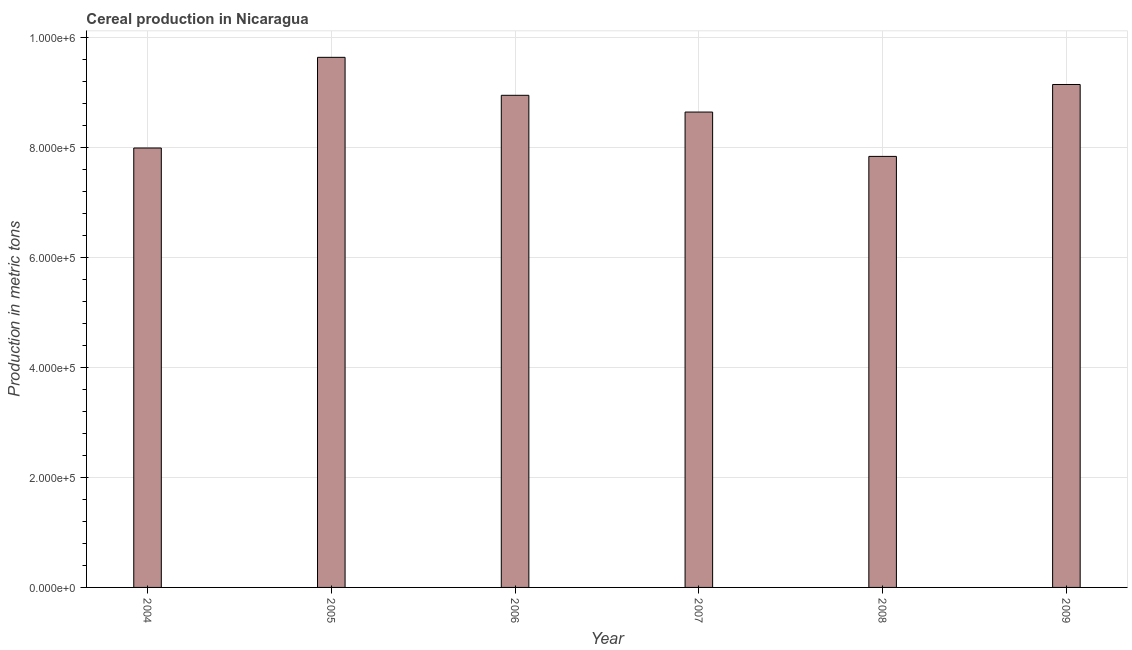Does the graph contain any zero values?
Your response must be concise. No. What is the title of the graph?
Give a very brief answer. Cereal production in Nicaragua. What is the label or title of the Y-axis?
Provide a succinct answer. Production in metric tons. What is the cereal production in 2006?
Provide a short and direct response. 8.95e+05. Across all years, what is the maximum cereal production?
Provide a short and direct response. 9.64e+05. Across all years, what is the minimum cereal production?
Provide a short and direct response. 7.84e+05. In which year was the cereal production maximum?
Give a very brief answer. 2005. What is the sum of the cereal production?
Provide a short and direct response. 5.22e+06. What is the difference between the cereal production in 2005 and 2006?
Provide a short and direct response. 6.90e+04. What is the average cereal production per year?
Give a very brief answer. 8.70e+05. What is the median cereal production?
Keep it short and to the point. 8.79e+05. Do a majority of the years between 2007 and 2005 (inclusive) have cereal production greater than 440000 metric tons?
Offer a very short reply. Yes. What is the ratio of the cereal production in 2007 to that in 2009?
Offer a very short reply. 0.94. What is the difference between the highest and the second highest cereal production?
Offer a terse response. 4.94e+04. Is the sum of the cereal production in 2006 and 2008 greater than the maximum cereal production across all years?
Provide a short and direct response. Yes. What is the difference between the highest and the lowest cereal production?
Your response must be concise. 1.80e+05. In how many years, is the cereal production greater than the average cereal production taken over all years?
Offer a very short reply. 3. How many bars are there?
Make the answer very short. 6. Are all the bars in the graph horizontal?
Provide a succinct answer. No. How many years are there in the graph?
Make the answer very short. 6. What is the Production in metric tons of 2004?
Your response must be concise. 7.99e+05. What is the Production in metric tons in 2005?
Your answer should be compact. 9.64e+05. What is the Production in metric tons in 2006?
Ensure brevity in your answer.  8.95e+05. What is the Production in metric tons of 2007?
Offer a very short reply. 8.64e+05. What is the Production in metric tons in 2008?
Your answer should be compact. 7.84e+05. What is the Production in metric tons of 2009?
Provide a succinct answer. 9.14e+05. What is the difference between the Production in metric tons in 2004 and 2005?
Offer a very short reply. -1.65e+05. What is the difference between the Production in metric tons in 2004 and 2006?
Give a very brief answer. -9.58e+04. What is the difference between the Production in metric tons in 2004 and 2007?
Ensure brevity in your answer.  -6.53e+04. What is the difference between the Production in metric tons in 2004 and 2008?
Give a very brief answer. 1.53e+04. What is the difference between the Production in metric tons in 2004 and 2009?
Give a very brief answer. -1.15e+05. What is the difference between the Production in metric tons in 2005 and 2006?
Your answer should be very brief. 6.90e+04. What is the difference between the Production in metric tons in 2005 and 2007?
Offer a very short reply. 9.95e+04. What is the difference between the Production in metric tons in 2005 and 2008?
Your answer should be very brief. 1.80e+05. What is the difference between the Production in metric tons in 2005 and 2009?
Offer a very short reply. 4.94e+04. What is the difference between the Production in metric tons in 2006 and 2007?
Provide a succinct answer. 3.04e+04. What is the difference between the Production in metric tons in 2006 and 2008?
Give a very brief answer. 1.11e+05. What is the difference between the Production in metric tons in 2006 and 2009?
Make the answer very short. -1.97e+04. What is the difference between the Production in metric tons in 2007 and 2008?
Provide a succinct answer. 8.06e+04. What is the difference between the Production in metric tons in 2007 and 2009?
Provide a short and direct response. -5.01e+04. What is the difference between the Production in metric tons in 2008 and 2009?
Provide a succinct answer. -1.31e+05. What is the ratio of the Production in metric tons in 2004 to that in 2005?
Provide a succinct answer. 0.83. What is the ratio of the Production in metric tons in 2004 to that in 2006?
Your response must be concise. 0.89. What is the ratio of the Production in metric tons in 2004 to that in 2007?
Give a very brief answer. 0.92. What is the ratio of the Production in metric tons in 2004 to that in 2008?
Provide a succinct answer. 1.02. What is the ratio of the Production in metric tons in 2004 to that in 2009?
Give a very brief answer. 0.87. What is the ratio of the Production in metric tons in 2005 to that in 2006?
Keep it short and to the point. 1.08. What is the ratio of the Production in metric tons in 2005 to that in 2007?
Your answer should be compact. 1.11. What is the ratio of the Production in metric tons in 2005 to that in 2008?
Offer a terse response. 1.23. What is the ratio of the Production in metric tons in 2005 to that in 2009?
Make the answer very short. 1.05. What is the ratio of the Production in metric tons in 2006 to that in 2007?
Ensure brevity in your answer.  1.03. What is the ratio of the Production in metric tons in 2006 to that in 2008?
Offer a very short reply. 1.14. What is the ratio of the Production in metric tons in 2007 to that in 2008?
Your answer should be very brief. 1.1. What is the ratio of the Production in metric tons in 2007 to that in 2009?
Offer a terse response. 0.94. What is the ratio of the Production in metric tons in 2008 to that in 2009?
Offer a very short reply. 0.86. 